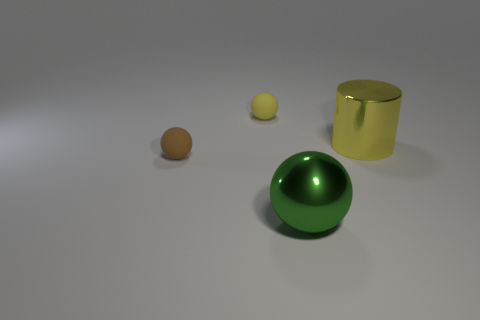Is there a rubber object of the same color as the shiny cylinder?
Provide a succinct answer. Yes. There is a big yellow metal cylinder that is on the right side of the brown thing; are there any yellow rubber objects behind it?
Keep it short and to the point. Yes. What number of brown metallic things are there?
Offer a terse response. 0. Does the big cylinder have the same color as the object that is behind the yellow cylinder?
Provide a succinct answer. Yes. Are there more large yellow cylinders than green rubber objects?
Give a very brief answer. Yes. Are there any other things of the same color as the metal cylinder?
Offer a terse response. Yes. How many other things are there of the same size as the green sphere?
Offer a very short reply. 1. The thing in front of the matte ball in front of the large metallic thing right of the large green object is made of what material?
Provide a succinct answer. Metal. Are the tiny brown sphere and the yellow object on the left side of the big yellow thing made of the same material?
Your answer should be very brief. Yes. Is the number of small yellow objects that are behind the small yellow matte thing less than the number of small rubber things that are right of the tiny brown matte sphere?
Your response must be concise. Yes. 